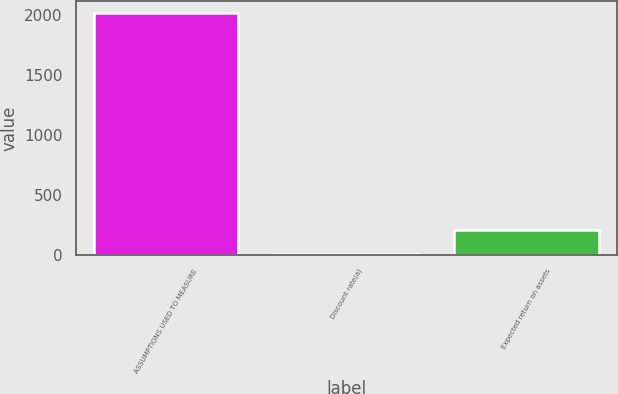Convert chart. <chart><loc_0><loc_0><loc_500><loc_500><bar_chart><fcel>ASSUMPTIONS USED TO MEASURE<fcel>Discount rate(a)<fcel>Expected return on assets<nl><fcel>2016<fcel>3.93<fcel>205.14<nl></chart> 